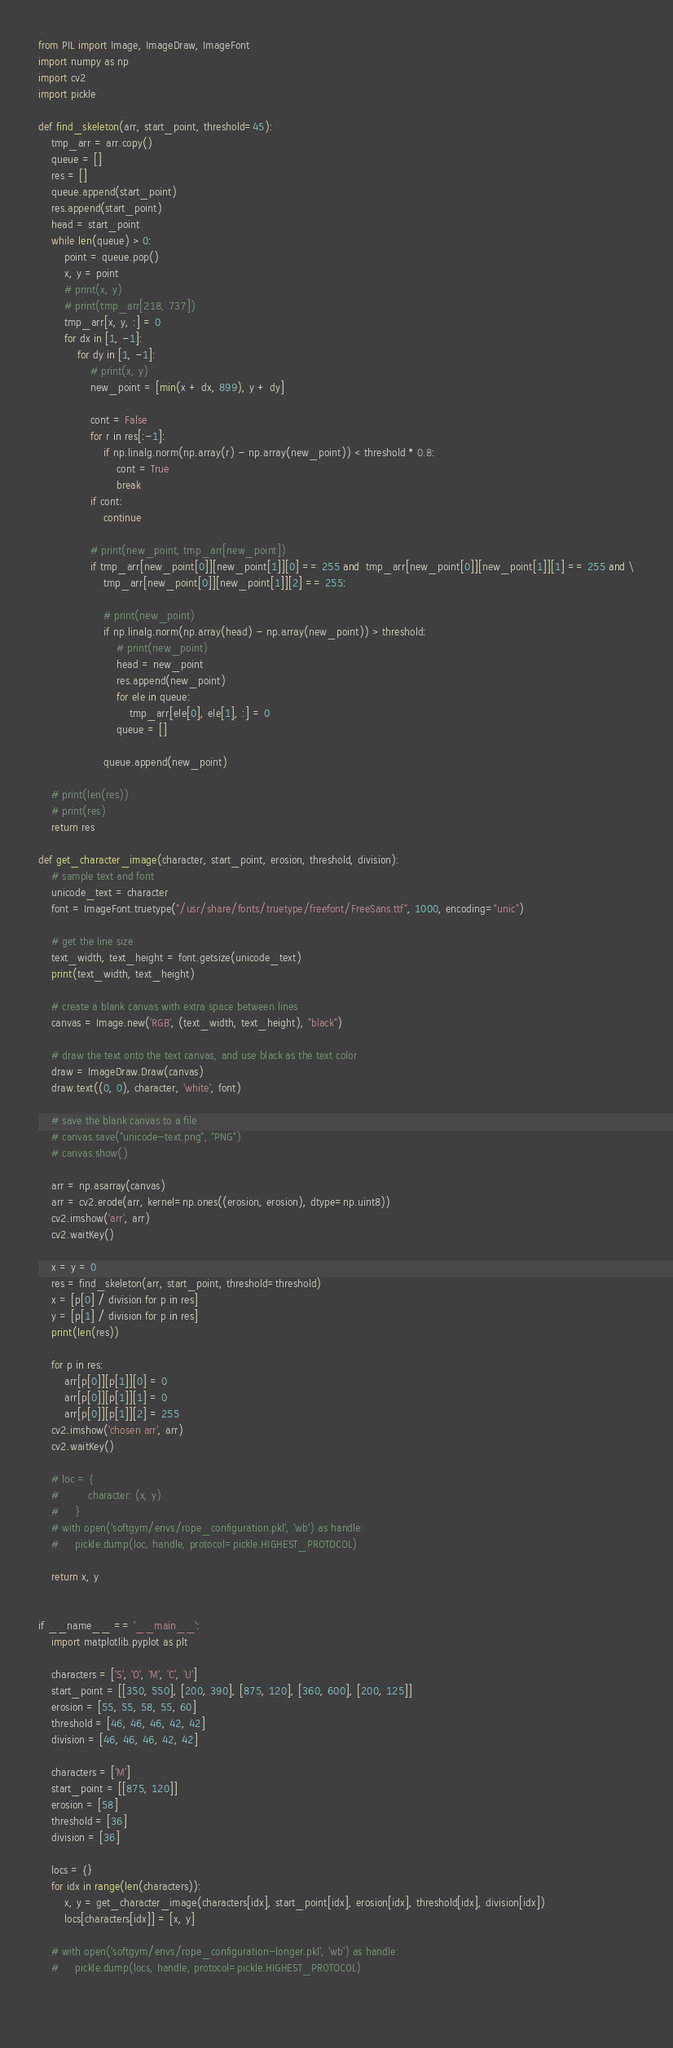<code> <loc_0><loc_0><loc_500><loc_500><_Python_>from PIL import Image, ImageDraw, ImageFont
import numpy as np
import cv2
import pickle

def find_skeleton(arr, start_point, threshold=45):
    tmp_arr = arr.copy()
    queue = []
    res = []
    queue.append(start_point)
    res.append(start_point)
    head = start_point
    while len(queue) > 0:
        point = queue.pop()
        x, y = point
        # print(x, y)
        # print(tmp_arr[218, 737])
        tmp_arr[x, y, :] = 0
        for dx in [1, -1]:
            for dy in [1, -1]:
                # print(x, y)
                new_point = [min(x + dx, 899), y + dy]

                cont = False
                for r in res[:-1]:
                    if np.linalg.norm(np.array(r) - np.array(new_point)) < threshold * 0.8:
                        cont = True
                        break
                if cont:
                    continue

                # print(new_point, tmp_arr[new_point])
                if tmp_arr[new_point[0]][new_point[1]][0] == 255 and  tmp_arr[new_point[0]][new_point[1]][1] == 255 and \
                    tmp_arr[new_point[0]][new_point[1]][2] == 255:
                    
                    # print(new_point)
                    if np.linalg.norm(np.array(head) - np.array(new_point)) > threshold:
                        # print(new_point)
                        head = new_point
                        res.append(new_point)
                        for ele in queue:
                            tmp_arr[ele[0], ele[1], :] = 0
                        queue = []

                    queue.append(new_point)

    # print(len(res))
    # print(res)
    return res

def get_character_image(character, start_point, erosion, threshold, division):
    # sample text and font
    unicode_text = character
    font = ImageFont.truetype("/usr/share/fonts/truetype/freefont/FreeSans.ttf", 1000, encoding="unic")

    # get the line size
    text_width, text_height = font.getsize(unicode_text)
    print(text_width, text_height)

    # create a blank canvas with extra space between lines
    canvas = Image.new('RGB', (text_width, text_height), "black")

    # draw the text onto the text canvas, and use black as the text color
    draw = ImageDraw.Draw(canvas)
    draw.text((0, 0), character, 'white', font)

    # save the blank canvas to a file
    # canvas.save("unicode-text.png", "PNG")
    # canvas.show()

    arr = np.asarray(canvas)
    arr = cv2.erode(arr, kernel=np.ones((erosion, erosion), dtype=np.uint8))
    cv2.imshow('arr', arr)
    cv2.waitKey()

    x = y = 0
    res = find_skeleton(arr, start_point, threshold=threshold)
    x = [p[0] / division for p in res]
    y = [p[1] / division for p in res]
    print(len(res))

    for p in res:
        arr[p[0]][p[1]][0] = 0
        arr[p[0]][p[1]][1] = 0
        arr[p[0]][p[1]][2] = 255
    cv2.imshow('chosen arr', arr)
    cv2.waitKey()
    
    # loc = {
    #         character: (x, y)
    #     }
    # with open('softgym/envs/rope_configuration.pkl', 'wb') as handle:
    #     pickle.dump(loc, handle, protocol=pickle.HIGHEST_PROTOCOL)

    return x, y


if __name__ == '__main__':
    import matplotlib.pyplot as plt

    characters = ['S', 'O', 'M', 'C', 'U']
    start_point = [[350, 550], [200, 390], [875, 120], [360, 600], [200, 125]]
    erosion = [55, 55, 58, 55, 60]
    threshold = [46, 46, 46, 42, 42]
    division = [46, 46, 46, 42, 42]

    characters = ['M']
    start_point = [[875, 120]]
    erosion = [58]
    threshold = [36]
    division = [36]

    locs = {}
    for idx in range(len(characters)):
        x, y = get_character_image(characters[idx], start_point[idx], erosion[idx], threshold[idx], division[idx])
        locs[characters[idx]] = [x, y]

    # with open('softgym/envs/rope_configuration-longer.pkl', 'wb') as handle:
    #     pickle.dump(locs, handle, protocol=pickle.HIGHEST_PROTOCOL)
    
    </code> 